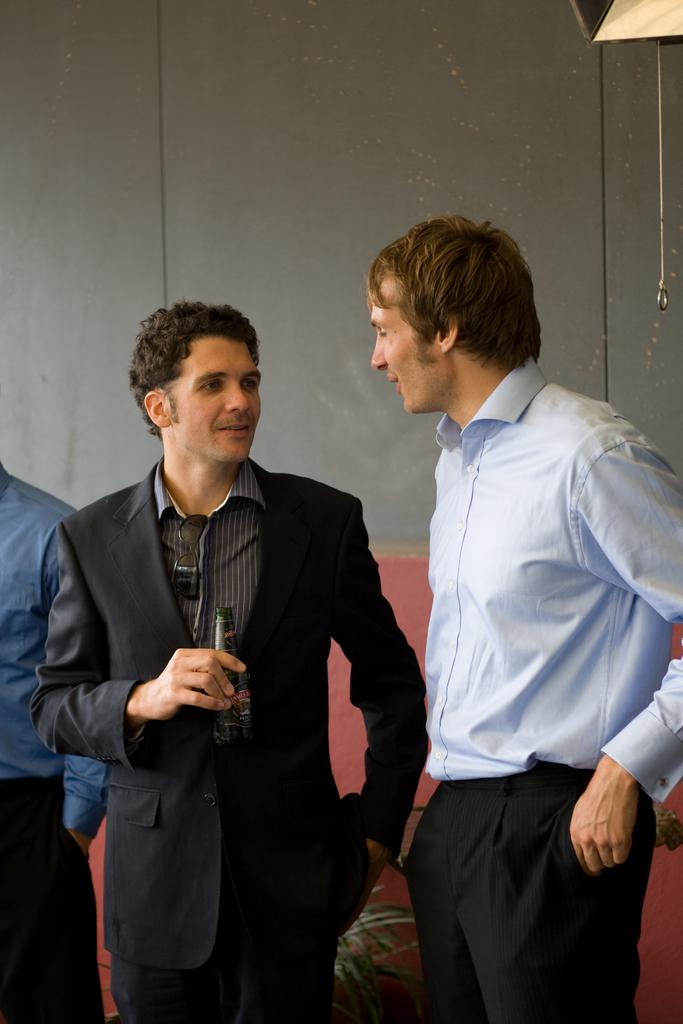How many people are in the image? There are three persons in the image. What is the background of the image? The persons are visible in front of a wall. What is the middle person holding? The middle person is holding a bottle. What type of statement is being made by the bulb in the image? There is no bulb present in the image, so it cannot make any statements. 